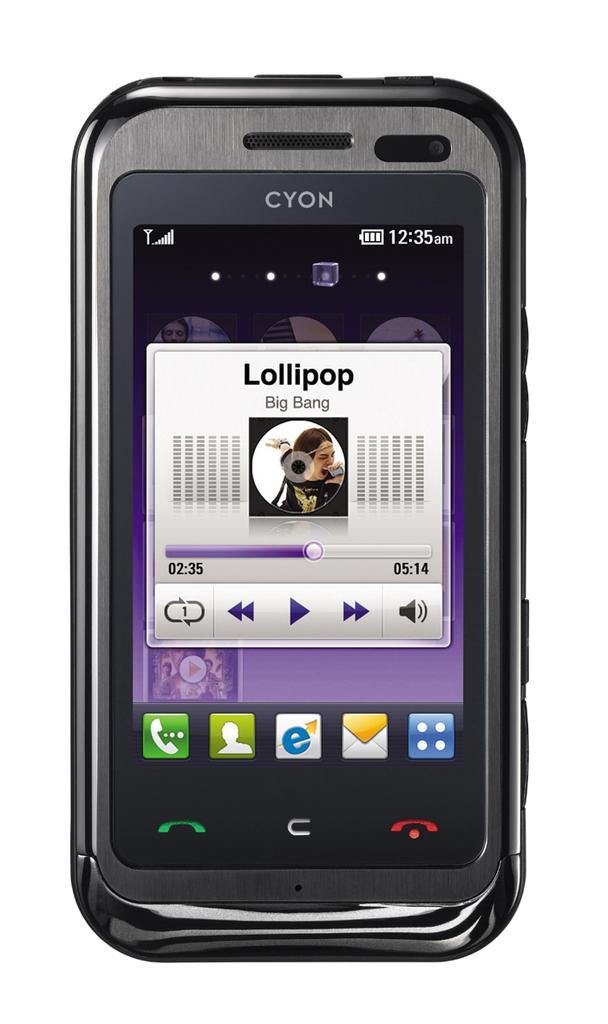Provide a one-sentence caption for the provided image. Lollipop by Big Bang is the name of the song playing on this CYON phone. 